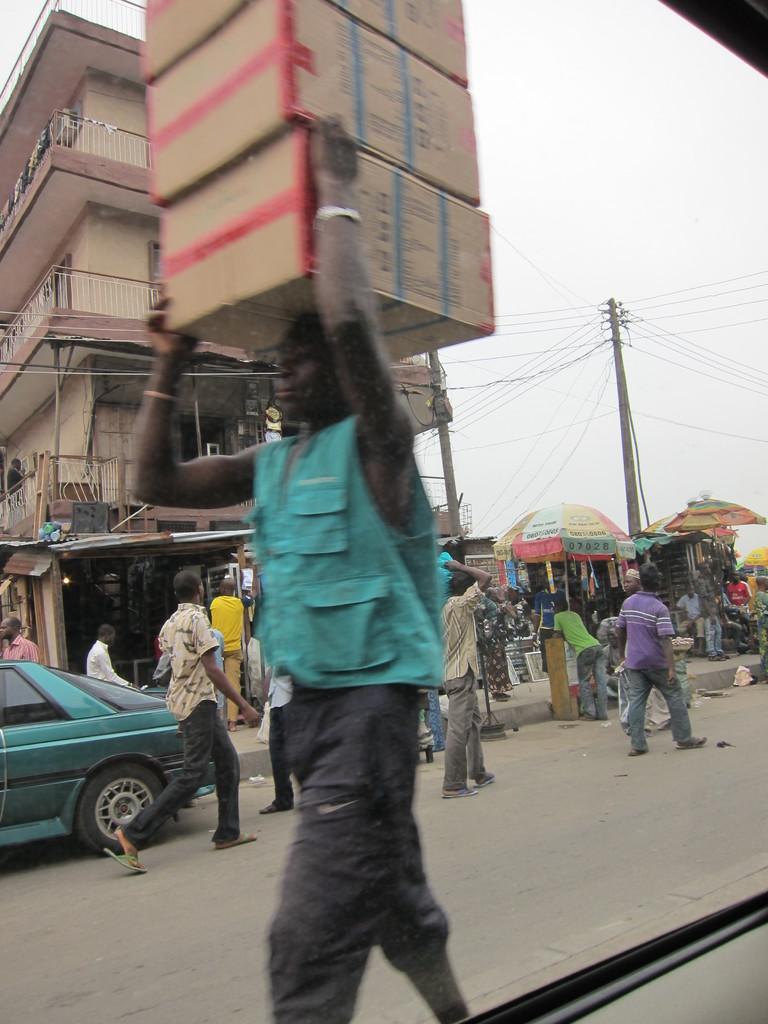In one or two sentences, can you explain what this image depicts? In the foreground I can see a person is holding carton boxes on the head. In the background I can see a crowd, vehicles on the road, tents, shops, buildings, poles and wires. At the top I can see the sky. This image is taken may be during a day. 